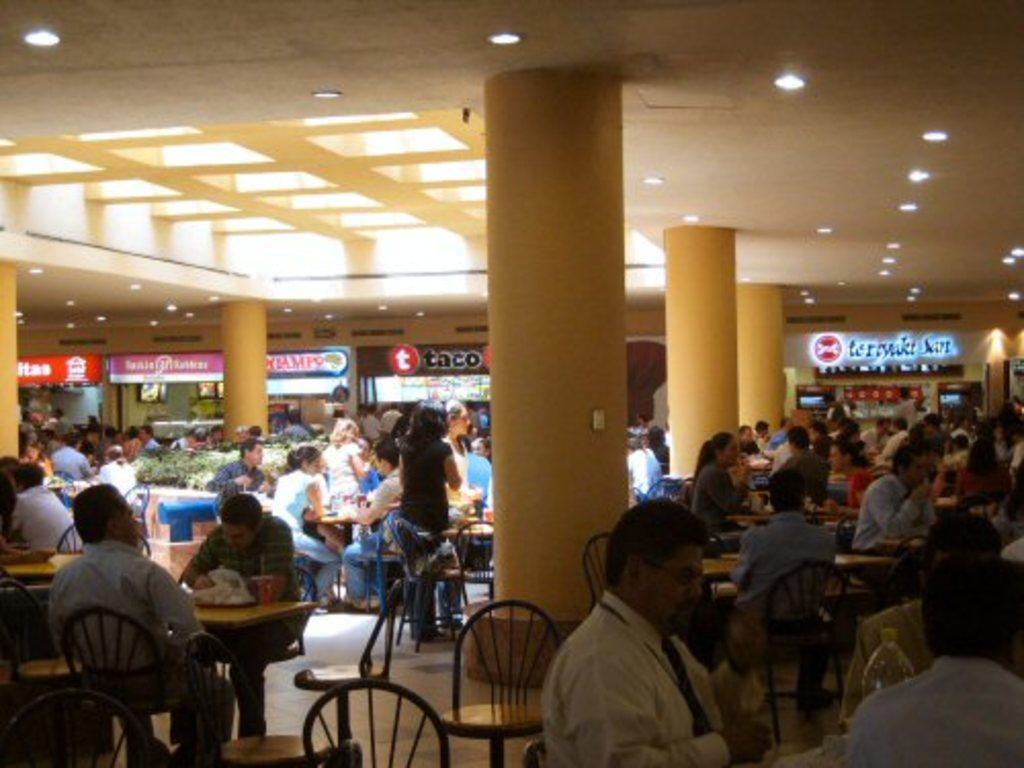In one or two sentences, can you explain what this image depicts? In this image we can see many persons are sitting on the chairs around the tables. 